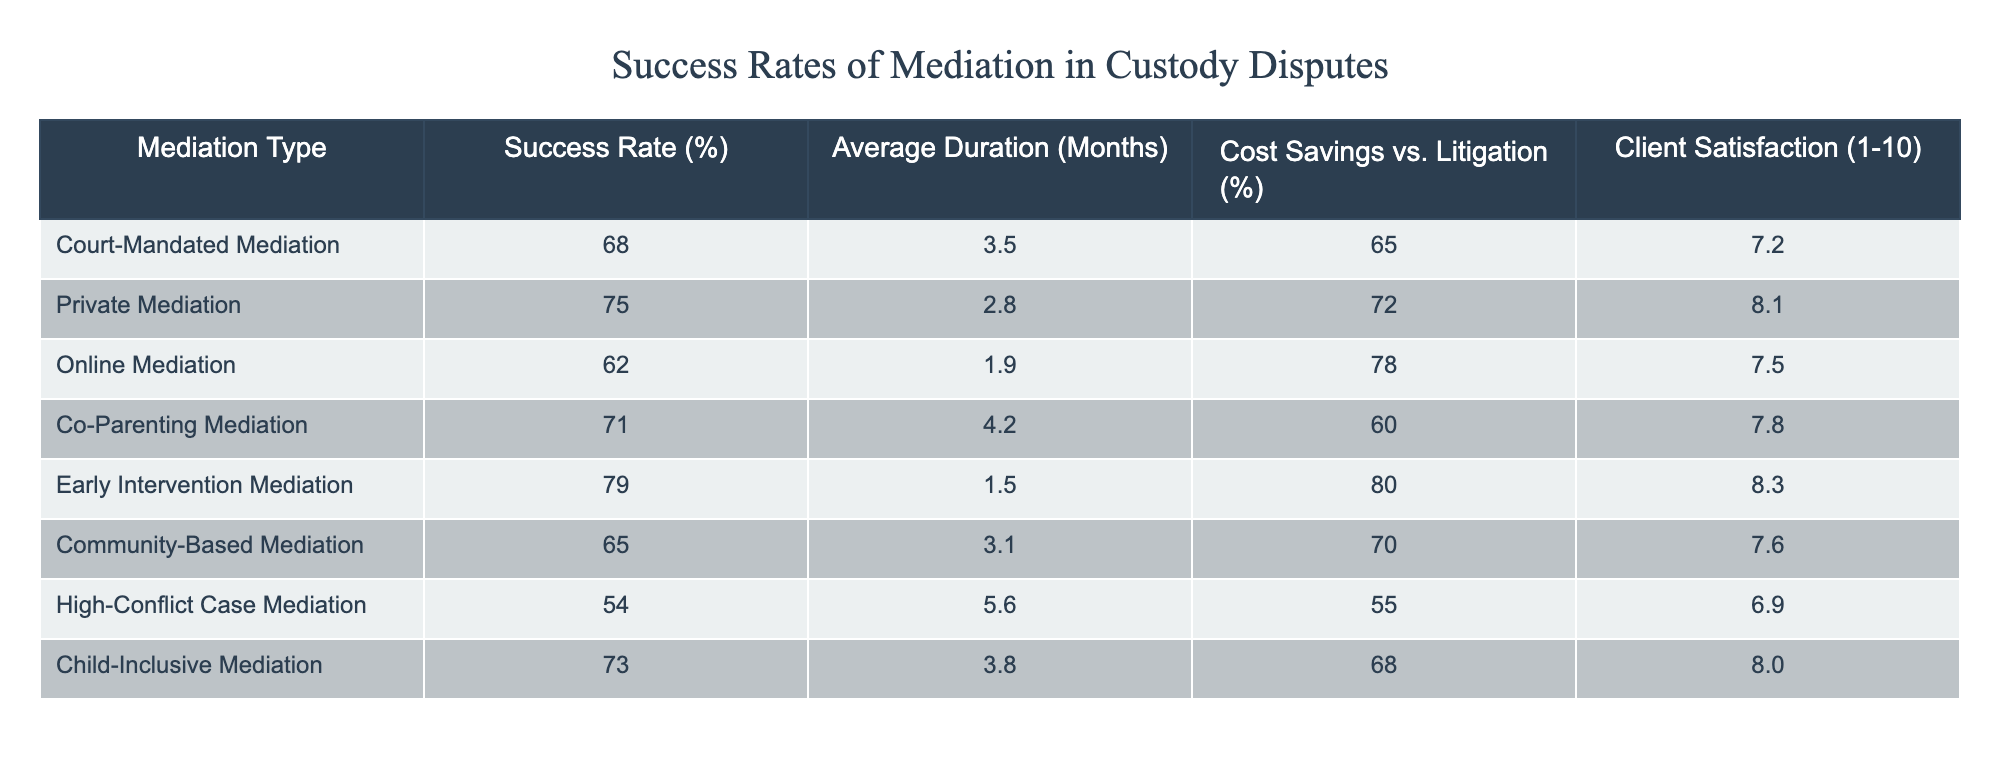What is the success rate of Private Mediation? The success rate for Private Mediation is listed in the second row of the table under the "Success Rate (%)" column, where it states 75%.
Answer: 75% Which type of mediation has the highest success rate? By examining the "Success Rate (%)" column, Early Intervention Mediation has the highest value at 79%.
Answer: Early Intervention Mediation True or False: Online Mediation has a higher client satisfaction rating than Co-Parenting Mediation. The client satisfaction rankings in the table show that Online Mediation has a rating of 7.5, while Co-Parenting Mediation has a rating of 7.8. Thus, the statement is false.
Answer: False What is the average success rate of all mediation types listed? To find the average success rate, sum the success rates (68 + 75 + 62 + 71 + 79 + 65 + 54 + 73) which equals 546, then divide by the number of mediation types (8). So, 546/8 = 68.25.
Answer: 68.25 Which type of mediation has the lowest cost savings compared to litigation? Looking at the "Cost Savings vs. Litigation (%)" column, High-Conflict Case Mediation has the lowest percentage at 55%.
Answer: High-Conflict Case Mediation How much longer, on average, does High-Conflict Case Mediation take compared to Early Intervention Mediation? High-Conflict Case Mediation has an average duration of 5.6 months, while Early Intervention Mediation takes 1.5 months. The difference is 5.6 - 1.5 = 4.1 months.
Answer: 4.1 months What is the client satisfaction rating for Court-Mandated Mediation? From the "Client Satisfaction (1-10)" column, the rating for Court-Mandated Mediation is 7.2.
Answer: 7.2 Is the average duration of Private Mediation shorter than that of Community-Based Mediation? The average duration for Private Mediation is 2.8 months, and for Community-Based Mediation, it is 3.1 months. Since 2.8 is less than 3.1, the answer to this question is yes.
Answer: Yes What two types of mediation have a success rate of 71% or higher? By reviewing the "Success Rate (%)" column, the types of mediation with rates of 71% or higher are Private Mediation (75%), Early Intervention Mediation (79%), Co-Parenting Mediation (71%), and Child-Inclusive Mediation (73%). Therefore, the answer is Co-Parenting Mediation and Private Mediation.
Answer: Co-Parenting Mediation and Private Mediation 